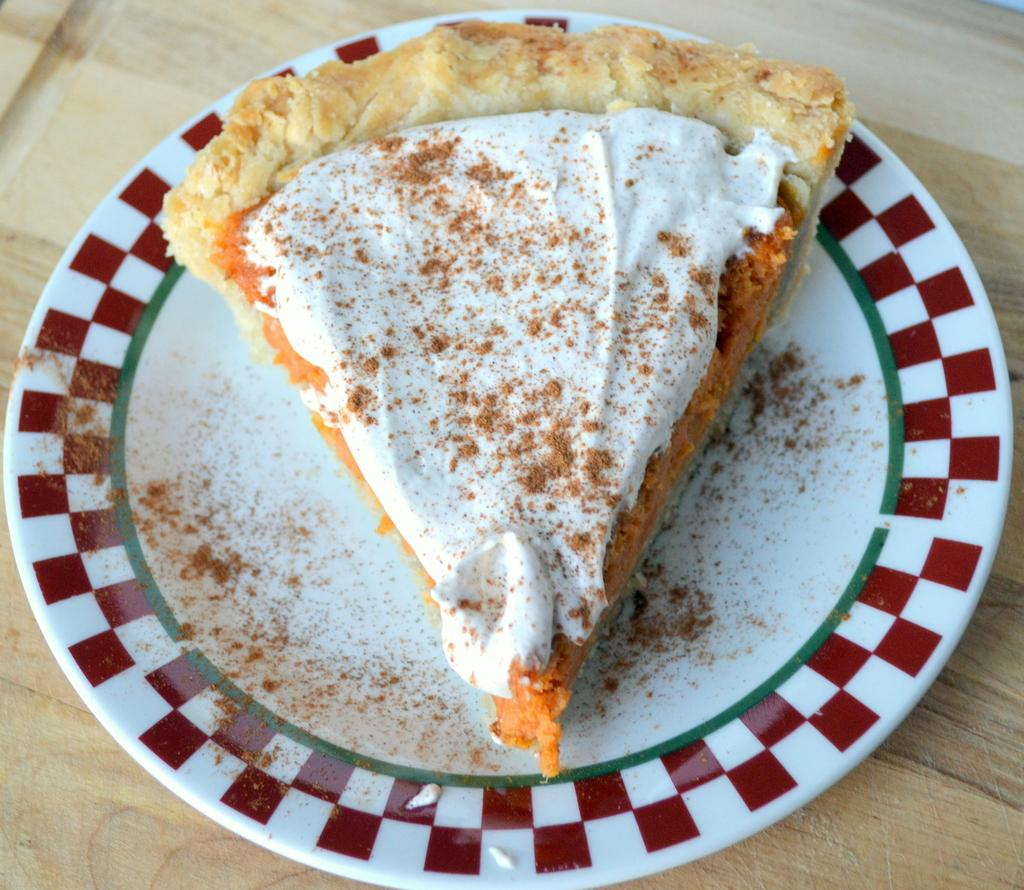What is present on the wooden surface in the image? There is a plate in the image. What is the shape of the food on the plate? The food on the plate is in a triangular shape. What type of surface is the plate placed on? The plate is placed on a wooden surface. What time does the clock on the plate indicate in the image? There is no clock present on the plate or in the image. 